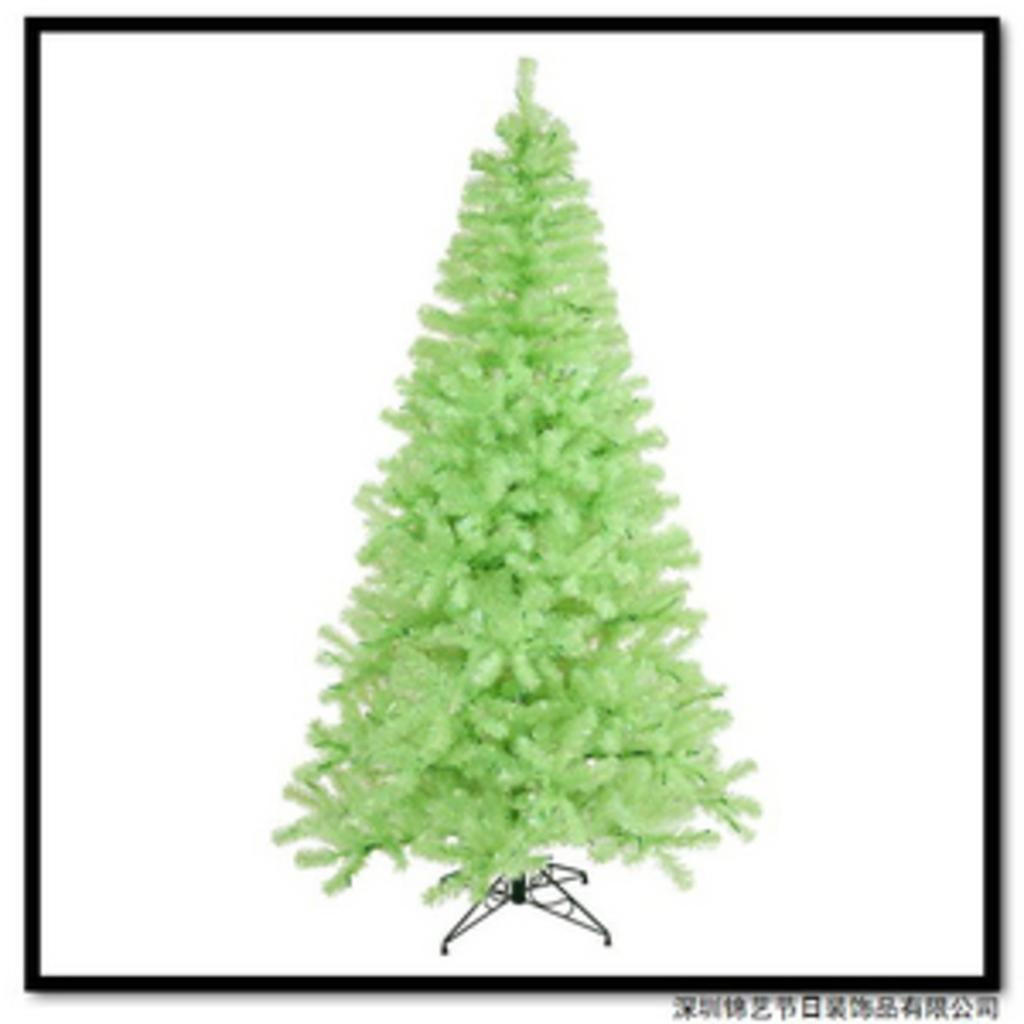What type of tree is present in the image? There is a plastic tree in the image. How is the plastic tree positioned in the image? The plastic tree is on a stand. Can you describe the setting in which the plastic tree is located? The image appears to be in a photo frame. Can you see any hills in the background of the image? There are no hills visible in the image; it features a plastic tree on a stand. Is there a mother figure interacting with the plastic tree in the image? There is no mother figure present in the image. 